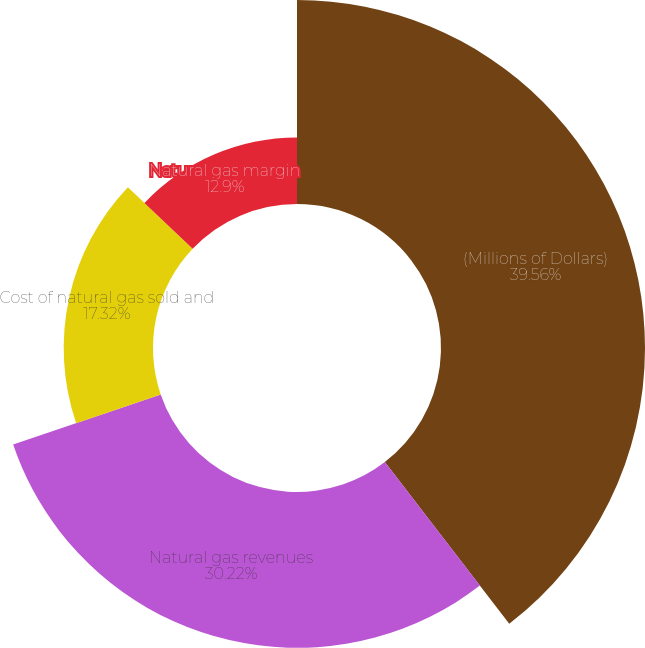Convert chart. <chart><loc_0><loc_0><loc_500><loc_500><pie_chart><fcel>(Millions of Dollars)<fcel>Natural gas revenues<fcel>Cost of natural gas sold and<fcel>Natural gas margin<nl><fcel>39.56%<fcel>30.22%<fcel>17.32%<fcel>12.9%<nl></chart> 